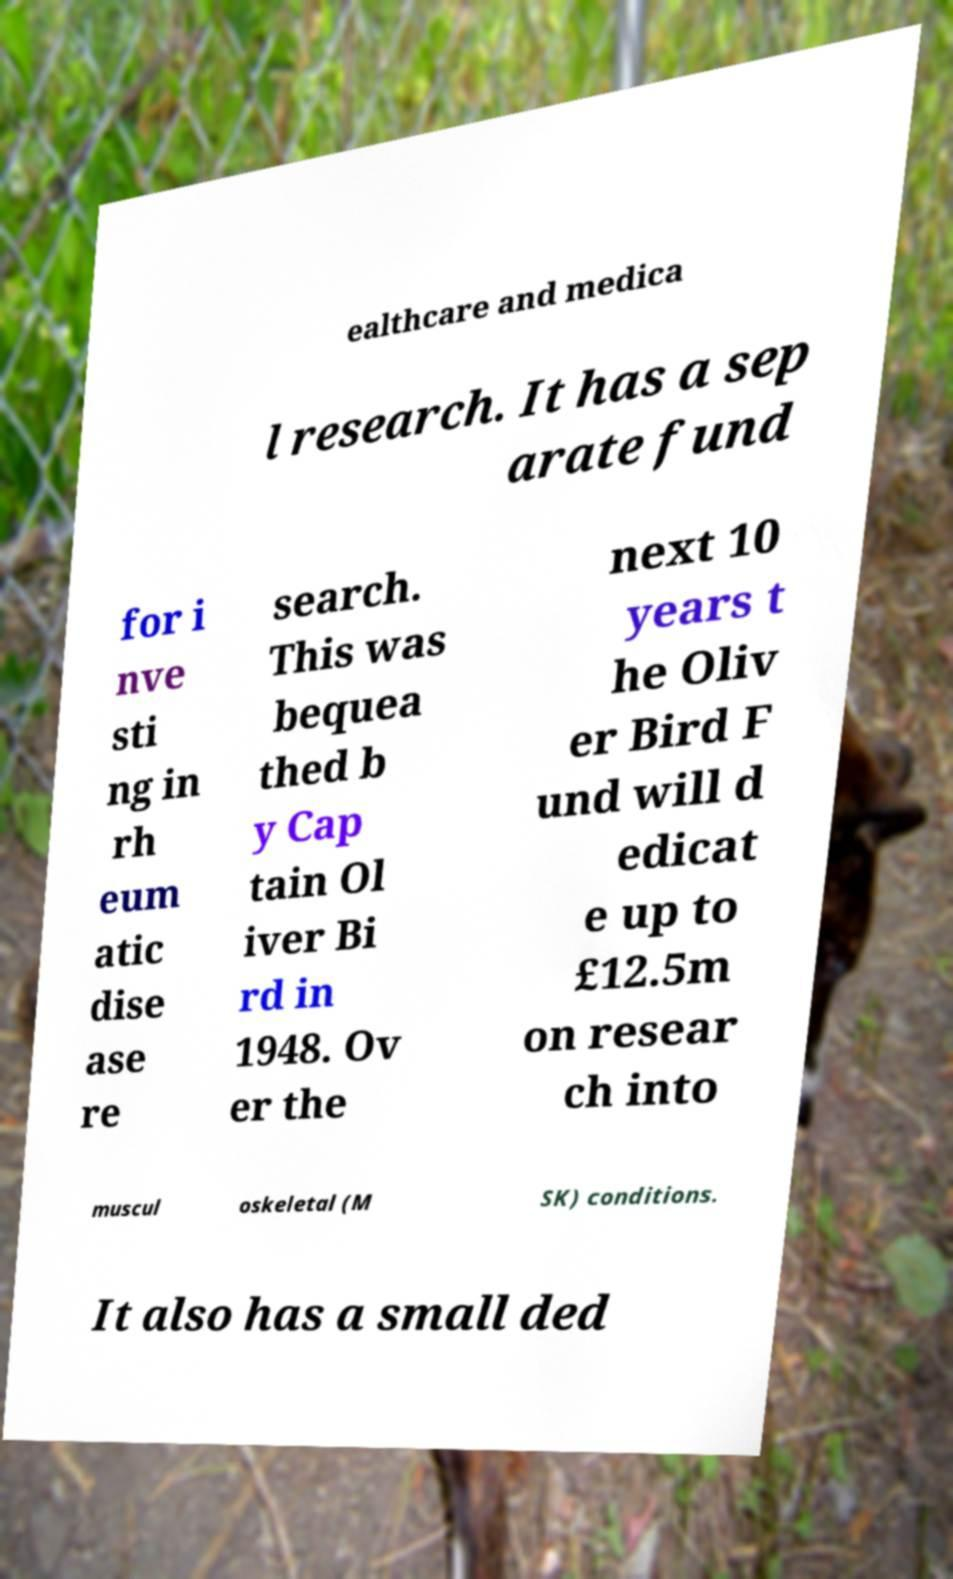Please read and relay the text visible in this image. What does it say? ealthcare and medica l research. It has a sep arate fund for i nve sti ng in rh eum atic dise ase re search. This was bequea thed b y Cap tain Ol iver Bi rd in 1948. Ov er the next 10 years t he Oliv er Bird F und will d edicat e up to £12.5m on resear ch into muscul oskeletal (M SK) conditions. It also has a small ded 